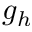<formula> <loc_0><loc_0><loc_500><loc_500>g _ { h }</formula> 